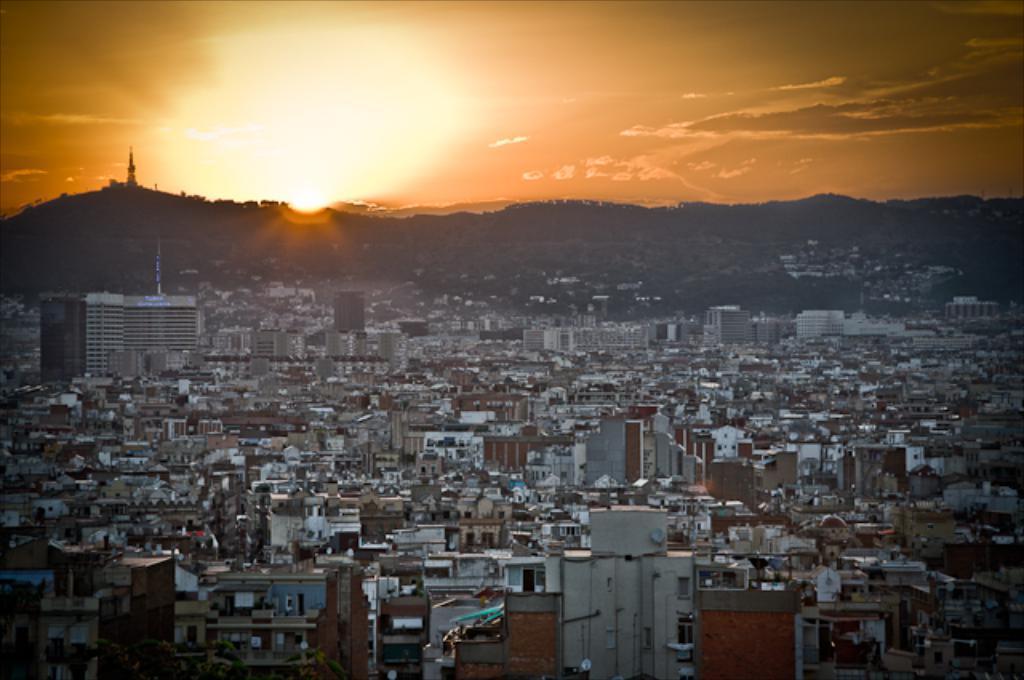In one or two sentences, can you explain what this image depicts? To the bottom of the image there are many buildings. In the background there are hills. And to the top of the image there is a sky with sun. 